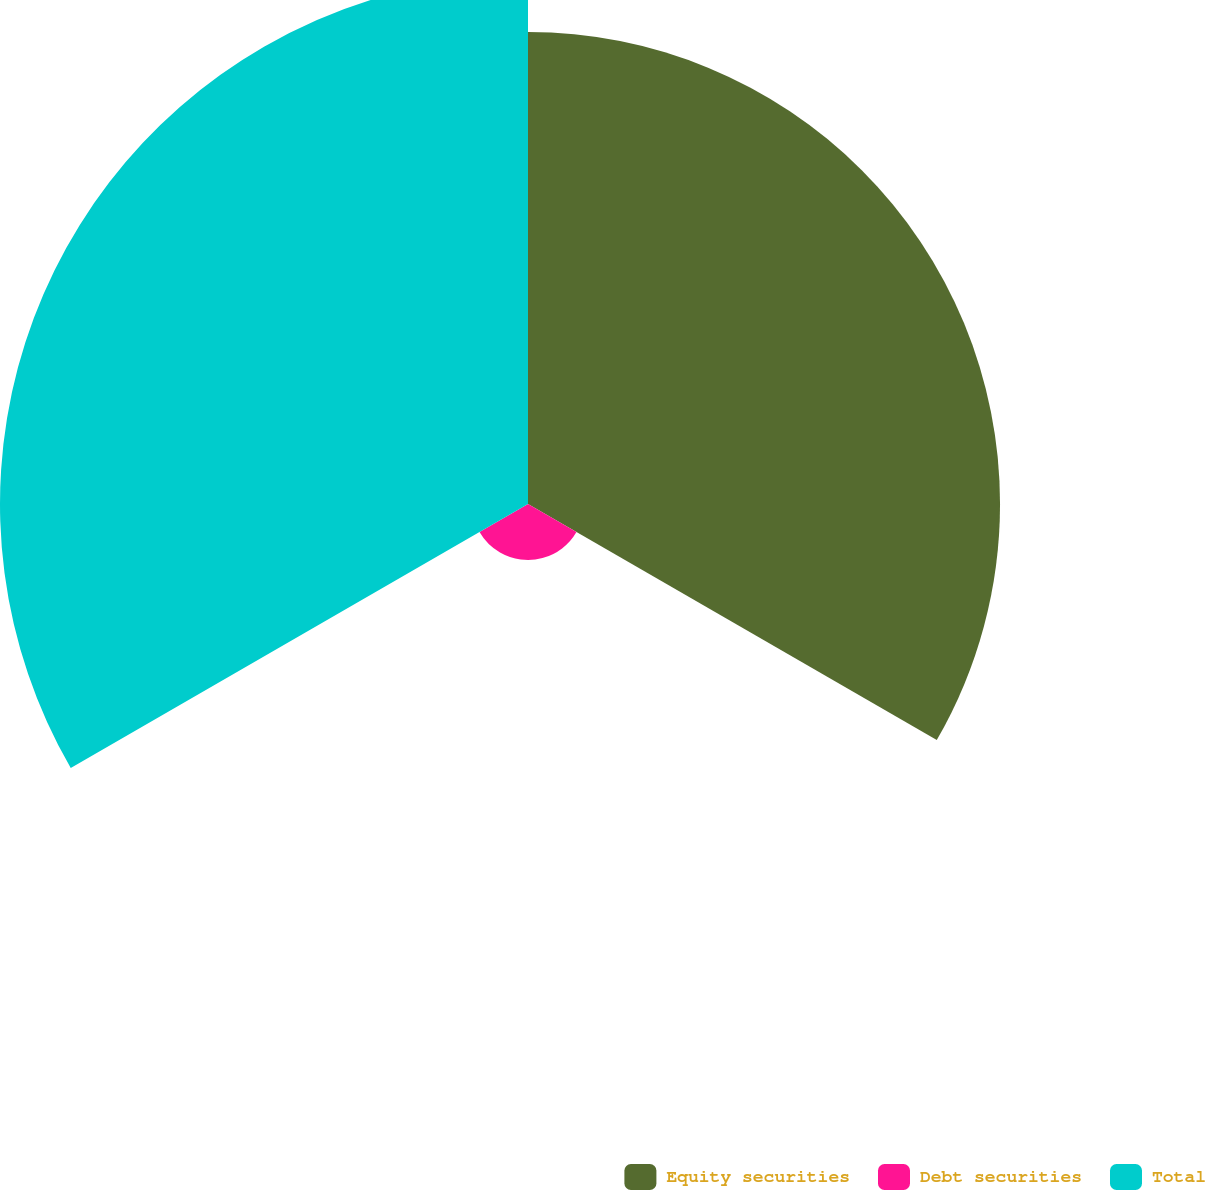Convert chart to OTSL. <chart><loc_0><loc_0><loc_500><loc_500><pie_chart><fcel>Equity securities<fcel>Debt securities<fcel>Total<nl><fcel>44.7%<fcel>5.3%<fcel>50.0%<nl></chart> 